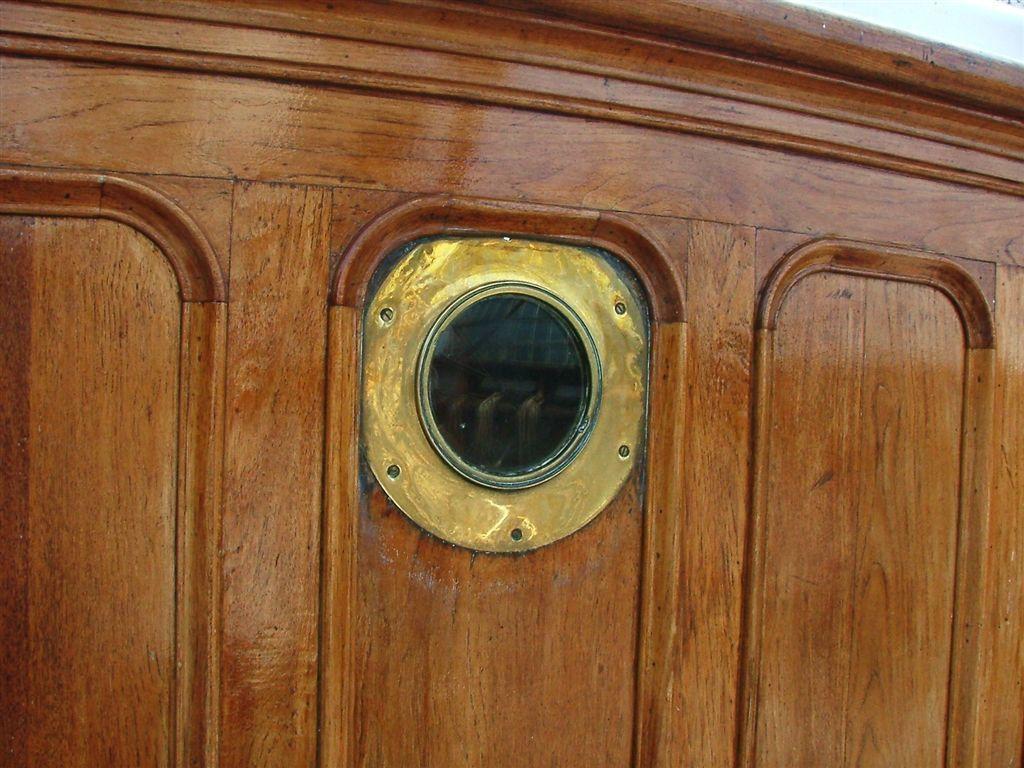Could you give a brief overview of what you see in this image? In the picture I can see the brass striped glass window on the wooden door. 